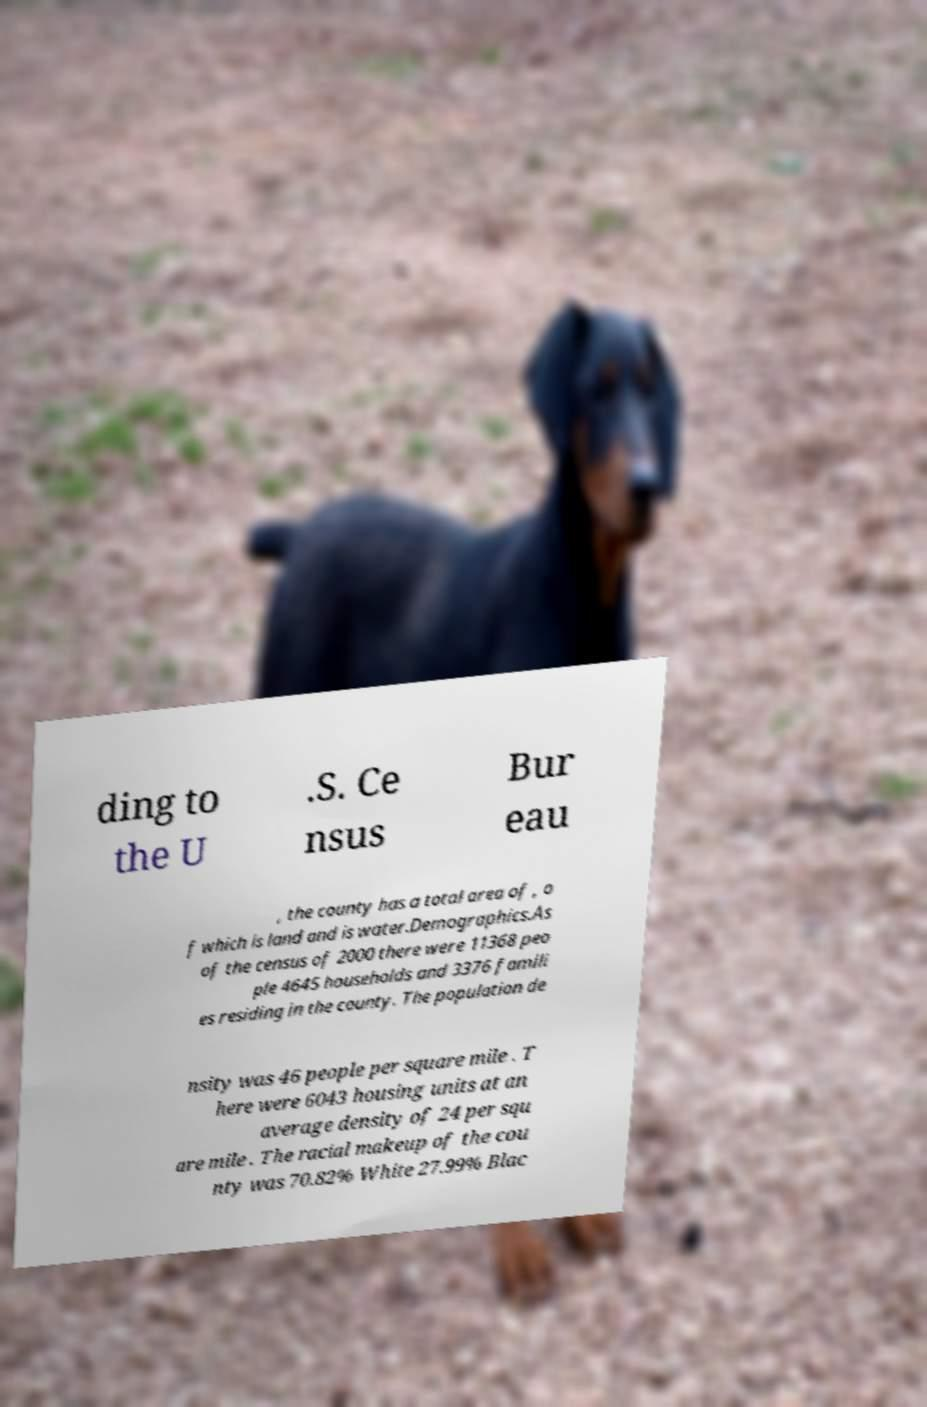Could you assist in decoding the text presented in this image and type it out clearly? ding to the U .S. Ce nsus Bur eau , the county has a total area of , o f which is land and is water.Demographics.As of the census of 2000 there were 11368 peo ple 4645 households and 3376 famili es residing in the county. The population de nsity was 46 people per square mile . T here were 6043 housing units at an average density of 24 per squ are mile . The racial makeup of the cou nty was 70.82% White 27.99% Blac 